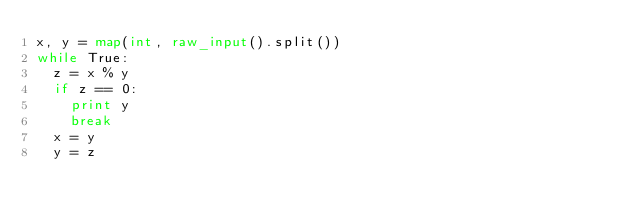<code> <loc_0><loc_0><loc_500><loc_500><_Python_>x, y = map(int, raw_input().split())
while True:
  z = x % y
  if z == 0:
    print y
    break
  x = y
  y = z</code> 